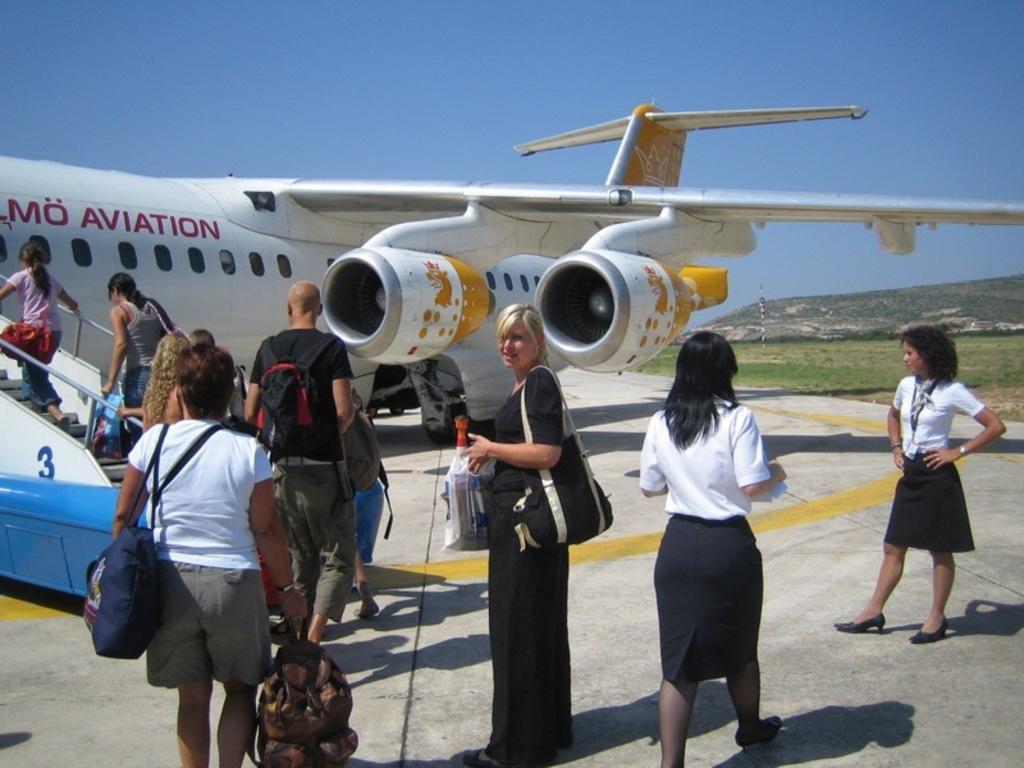Could you give a brief overview of what you see in this image? In front of the picture, we see three women are standing. We see the passengers boarding the exterior steps. In front of them, we see an airplane in white color and it is on the runway. On the right side, we see a pole, grass, trees and the hills. At the top, we see the sky, which is blue in color. 